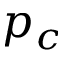Convert formula to latex. <formula><loc_0><loc_0><loc_500><loc_500>p _ { c }</formula> 